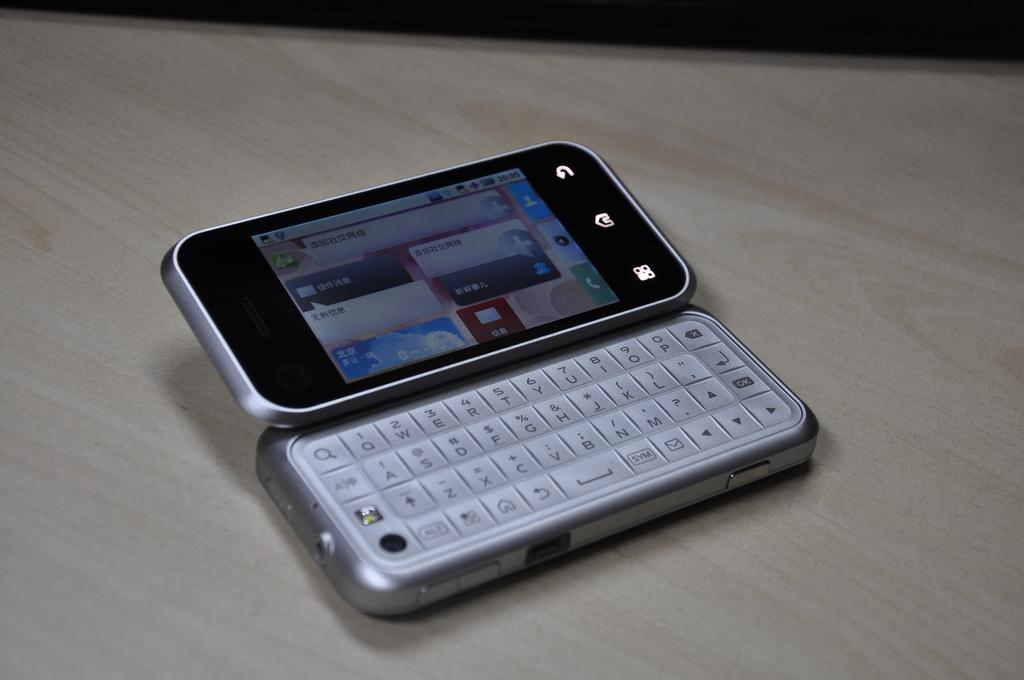<image>
Create a compact narrative representing the image presented. A cellphone sitting on a table with chinese writing on the screen but the keyboard has english letters like A,B,C,D. 